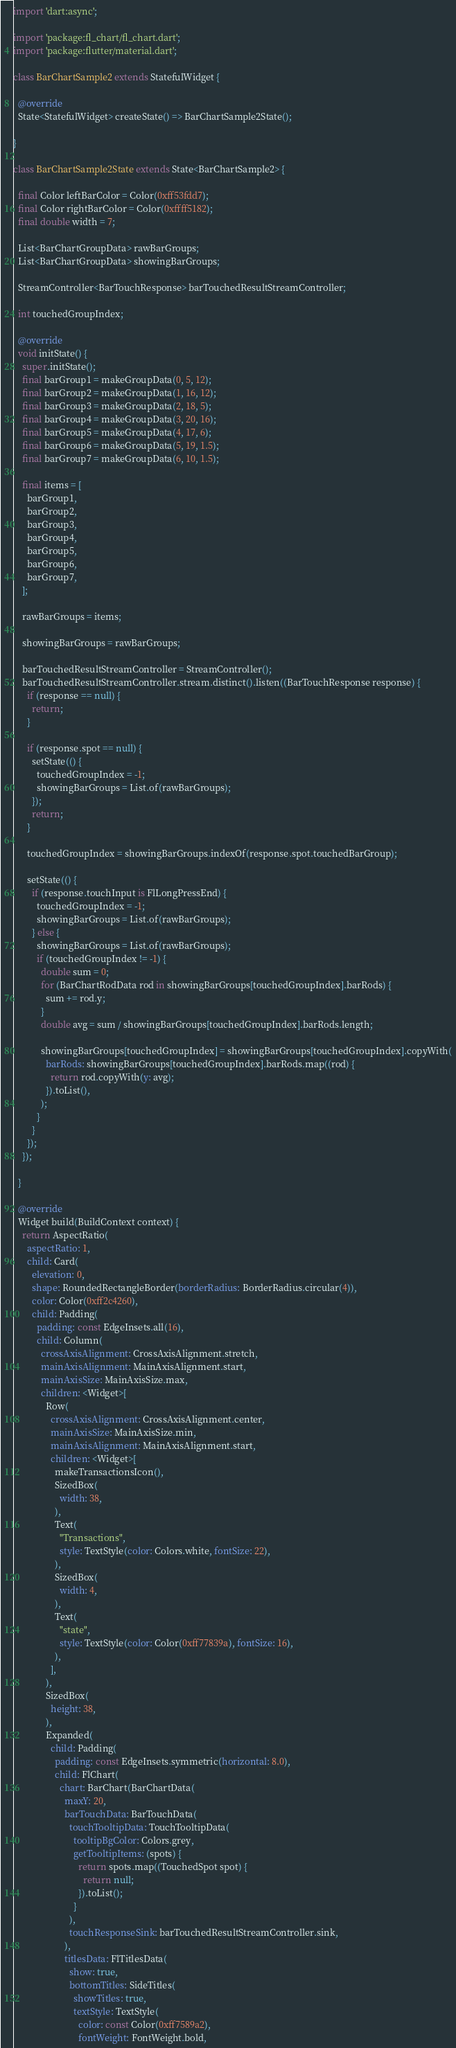<code> <loc_0><loc_0><loc_500><loc_500><_Dart_>import 'dart:async';

import 'package:fl_chart/fl_chart.dart';
import 'package:flutter/material.dart';

class BarChartSample2 extends StatefulWidget {

  @override
  State<StatefulWidget> createState() => BarChartSample2State();

}

class BarChartSample2State extends State<BarChartSample2> {

  final Color leftBarColor = Color(0xff53fdd7);
  final Color rightBarColor = Color(0xffff5182);
  final double width = 7;

  List<BarChartGroupData> rawBarGroups;
  List<BarChartGroupData> showingBarGroups;

  StreamController<BarTouchResponse> barTouchedResultStreamController;

  int touchedGroupIndex;

  @override
  void initState() {
    super.initState();
    final barGroup1 = makeGroupData(0, 5, 12);
    final barGroup2 = makeGroupData(1, 16, 12);
    final barGroup3 = makeGroupData(2, 18, 5);
    final barGroup4 = makeGroupData(3, 20, 16);
    final barGroup5 = makeGroupData(4, 17, 6);
    final barGroup6 = makeGroupData(5, 19, 1.5);
    final barGroup7 = makeGroupData(6, 10, 1.5);

    final items = [
      barGroup1,
      barGroup2,
      barGroup3,
      barGroup4,
      barGroup5,
      barGroup6,
      barGroup7,
    ];

    rawBarGroups = items;

    showingBarGroups = rawBarGroups;

    barTouchedResultStreamController = StreamController();
    barTouchedResultStreamController.stream.distinct().listen((BarTouchResponse response) {
      if (response == null) {
        return;
      }

      if (response.spot == null) {
        setState(() {
          touchedGroupIndex = -1;
          showingBarGroups = List.of(rawBarGroups);
        });
        return;
      }

      touchedGroupIndex = showingBarGroups.indexOf(response.spot.touchedBarGroup);

      setState(() {
        if (response.touchInput is FlLongPressEnd) {
          touchedGroupIndex = -1;
          showingBarGroups = List.of(rawBarGroups);
        } else {
          showingBarGroups = List.of(rawBarGroups);
          if (touchedGroupIndex != -1) {
            double sum = 0;
            for (BarChartRodData rod in showingBarGroups[touchedGroupIndex].barRods) {
              sum += rod.y;
            }
            double avg = sum / showingBarGroups[touchedGroupIndex].barRods.length;

            showingBarGroups[touchedGroupIndex] = showingBarGroups[touchedGroupIndex].copyWith(
              barRods: showingBarGroups[touchedGroupIndex].barRods.map((rod) {
                return rod.copyWith(y: avg);
              }).toList(),
            );
          }
        }
      });
    });

  }

  @override
  Widget build(BuildContext context) {
    return AspectRatio(
      aspectRatio: 1,
      child: Card(
        elevation: 0,
        shape: RoundedRectangleBorder(borderRadius: BorderRadius.circular(4)),
        color: Color(0xff2c4260),
        child: Padding(
          padding: const EdgeInsets.all(16),
          child: Column(
            crossAxisAlignment: CrossAxisAlignment.stretch,
            mainAxisAlignment: MainAxisAlignment.start,
            mainAxisSize: MainAxisSize.max,
            children: <Widget>[
              Row(
                crossAxisAlignment: CrossAxisAlignment.center,
                mainAxisSize: MainAxisSize.min,
                mainAxisAlignment: MainAxisAlignment.start,
                children: <Widget>[
                  makeTransactionsIcon(),
                  SizedBox(
                    width: 38,
                  ),
                  Text(
                    "Transactions",
                    style: TextStyle(color: Colors.white, fontSize: 22),
                  ),
                  SizedBox(
                    width: 4,
                  ),
                  Text(
                    "state",
                    style: TextStyle(color: Color(0xff77839a), fontSize: 16),
                  ),
                ],
              ),
              SizedBox(
                height: 38,
              ),
              Expanded(
                child: Padding(
                  padding: const EdgeInsets.symmetric(horizontal: 8.0),
                  child: FlChart(
                    chart: BarChart(BarChartData(
                      maxY: 20,
                      barTouchData: BarTouchData(
                        touchTooltipData: TouchTooltipData(
                          tooltipBgColor: Colors.grey,
                          getTooltipItems: (spots) {
                            return spots.map((TouchedSpot spot) {
                              return null;
                            }).toList();
                          }
                        ),
                        touchResponseSink: barTouchedResultStreamController.sink,
                      ),
                      titlesData: FlTitlesData(
                        show: true,
                        bottomTitles: SideTitles(
                          showTitles: true,
                          textStyle: TextStyle(
                            color: const Color(0xff7589a2),
                            fontWeight: FontWeight.bold,</code> 